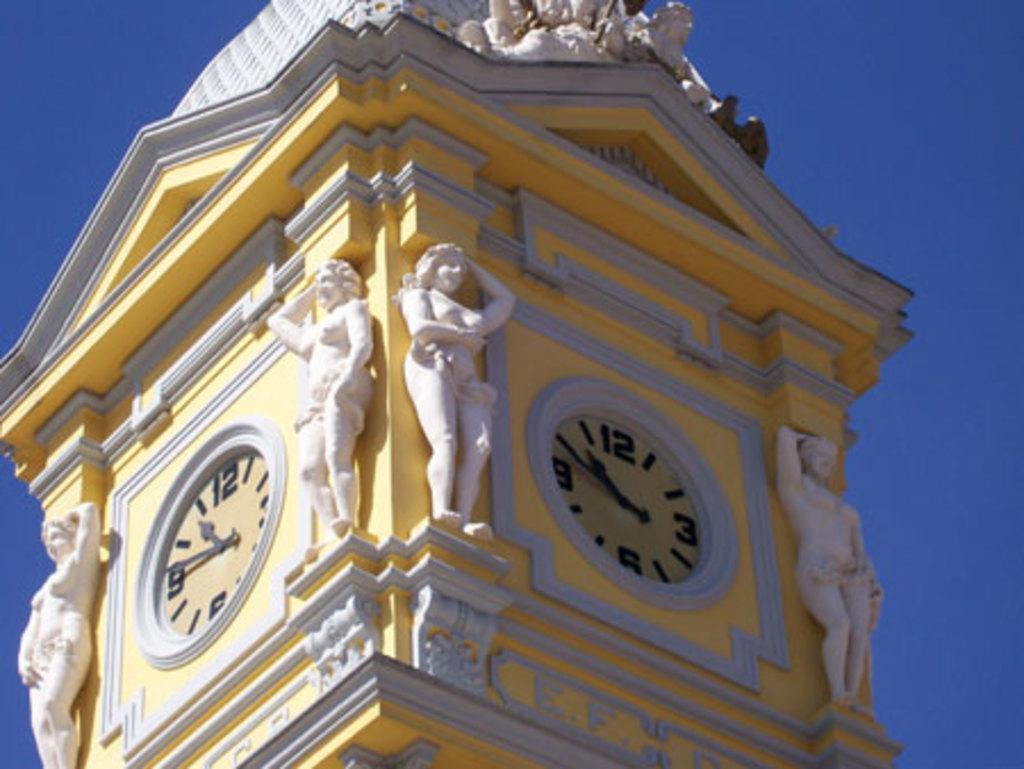Please provide a concise description of this image. In this image we can see a building with clocks and sculptures on it. In the back there is sky. 